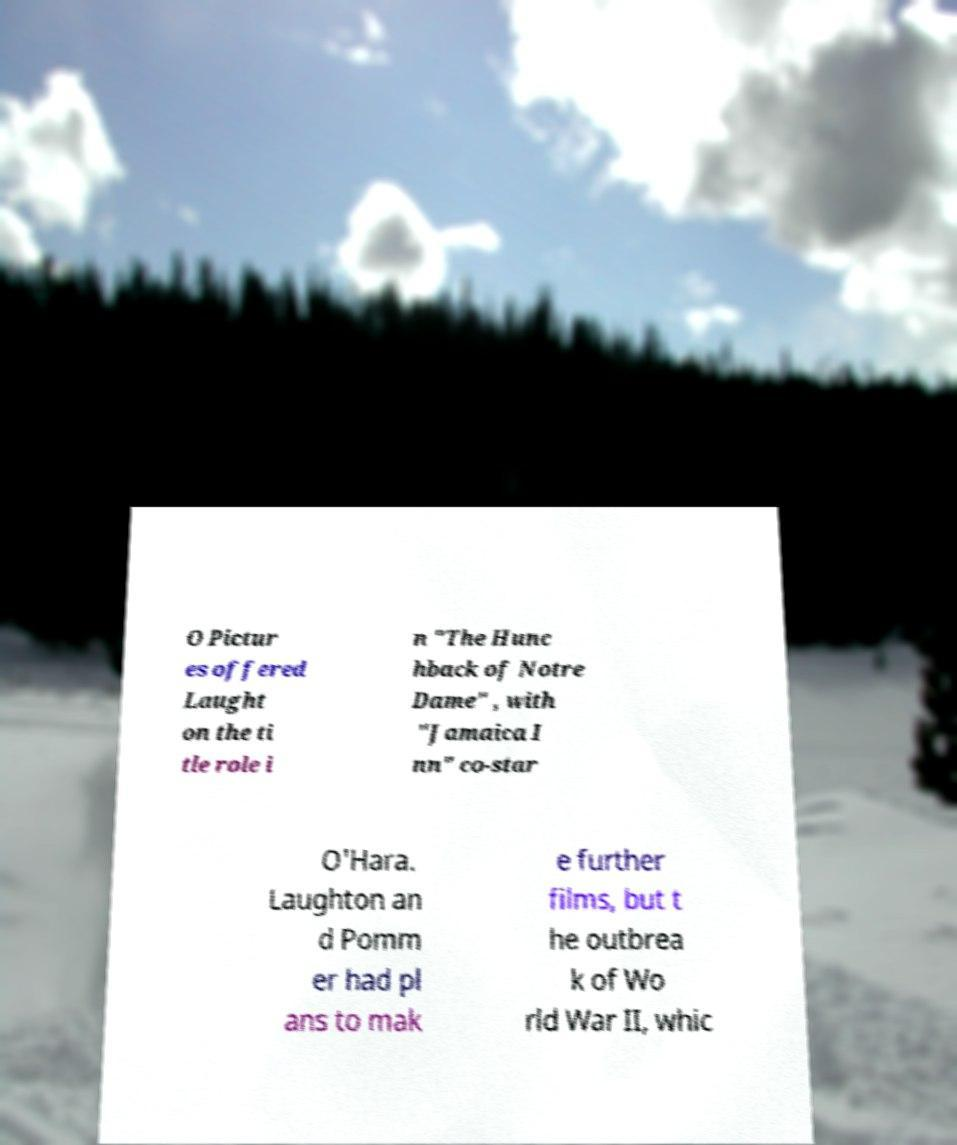Could you assist in decoding the text presented in this image and type it out clearly? O Pictur es offered Laught on the ti tle role i n "The Hunc hback of Notre Dame" , with "Jamaica I nn" co-star O'Hara. Laughton an d Pomm er had pl ans to mak e further films, but t he outbrea k of Wo rld War II, whic 